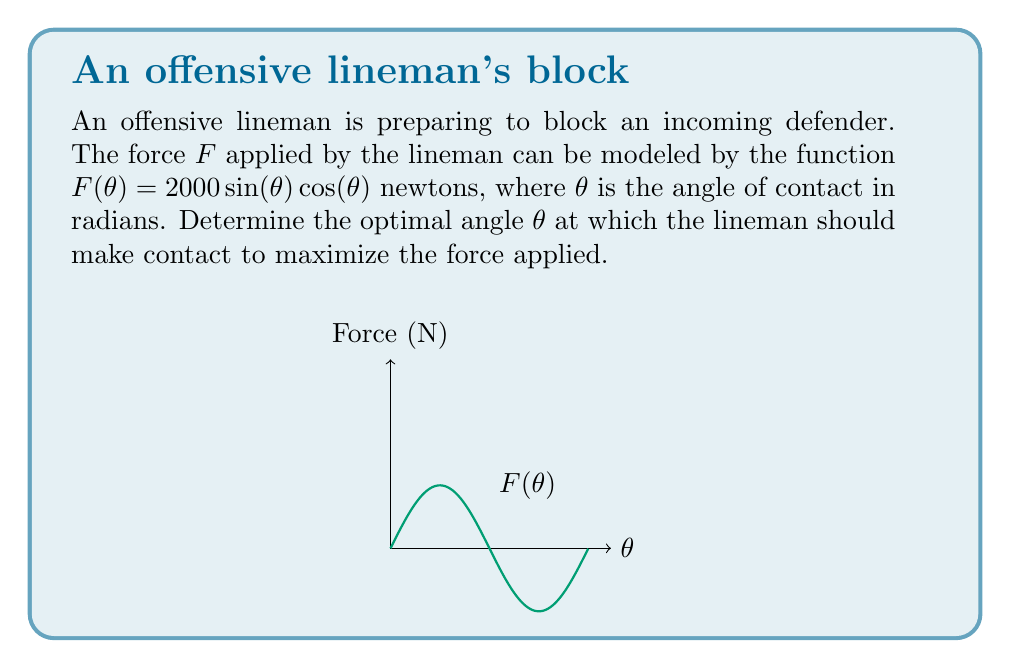Give your solution to this math problem. To find the optimal angle that maximizes the force, we need to find the maximum of the function $F(\theta) = 2000 \sin(\theta) \cos(\theta)$.

Step 1: Simplify the function using the trigonometric identity $\sin(2\theta) = 2\sin(\theta)\cos(\theta)$:
$$F(\theta) = 2000 \sin(\theta) \cos(\theta) = 1000 \sin(2\theta)$$

Step 2: To find the maximum, we need to find where the derivative of $F(\theta)$ equals zero:
$$\frac{dF}{d\theta} = 1000 \cdot 2 \cos(2\theta) = 2000 \cos(2\theta)$$

Step 3: Set the derivative to zero and solve for $\theta$:
$$2000 \cos(2\theta) = 0$$
$$\cos(2\theta) = 0$$
$$2\theta = \frac{\pi}{2} + n\pi, \text{ where } n \text{ is an integer}$$
$$\theta = \frac{\pi}{4} + \frac{n\pi}{2}$$

Step 4: The smallest positive solution is $\theta = \frac{\pi}{4}$ radians, which is equivalent to 45 degrees.

Step 5: Verify this is a maximum by checking the second derivative:
$$\frac{d^2F}{d\theta^2} = -4000 \sin(2\theta)$$
At $\theta = \frac{\pi}{4}$, $\frac{d^2F}{d\theta^2} < 0$, confirming it's a maximum.
Answer: $\frac{\pi}{4}$ radians or 45° 